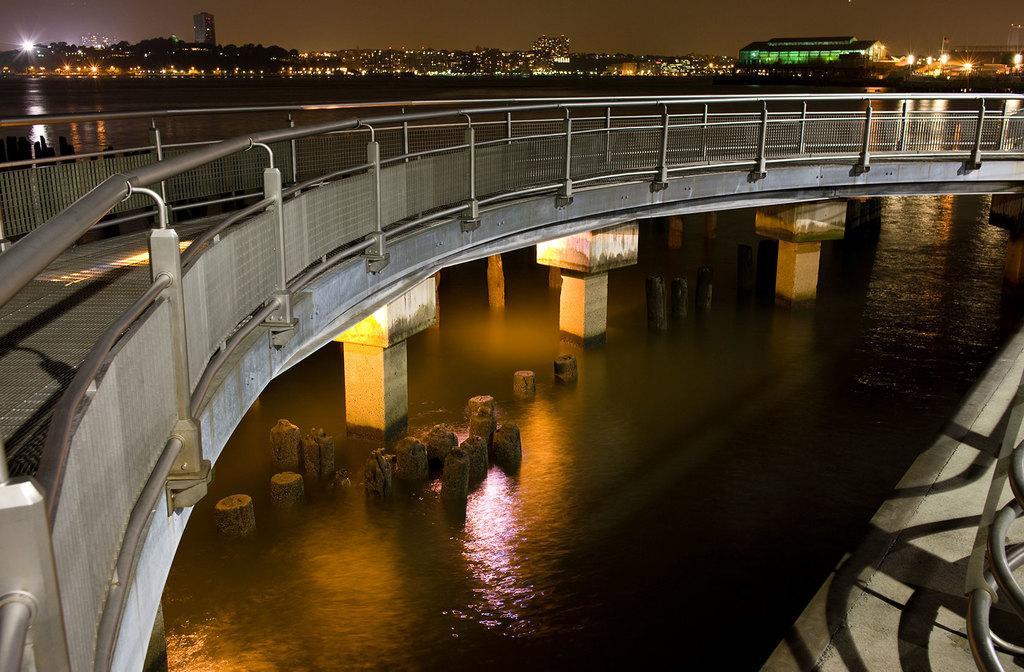In one or two sentences, can you explain what this image depicts? This image is taken during the night time. In this image we can see the bridge, wooden pillars, water and in the background we can see the buildings with lightning. We can also see the lights and also the sky. 